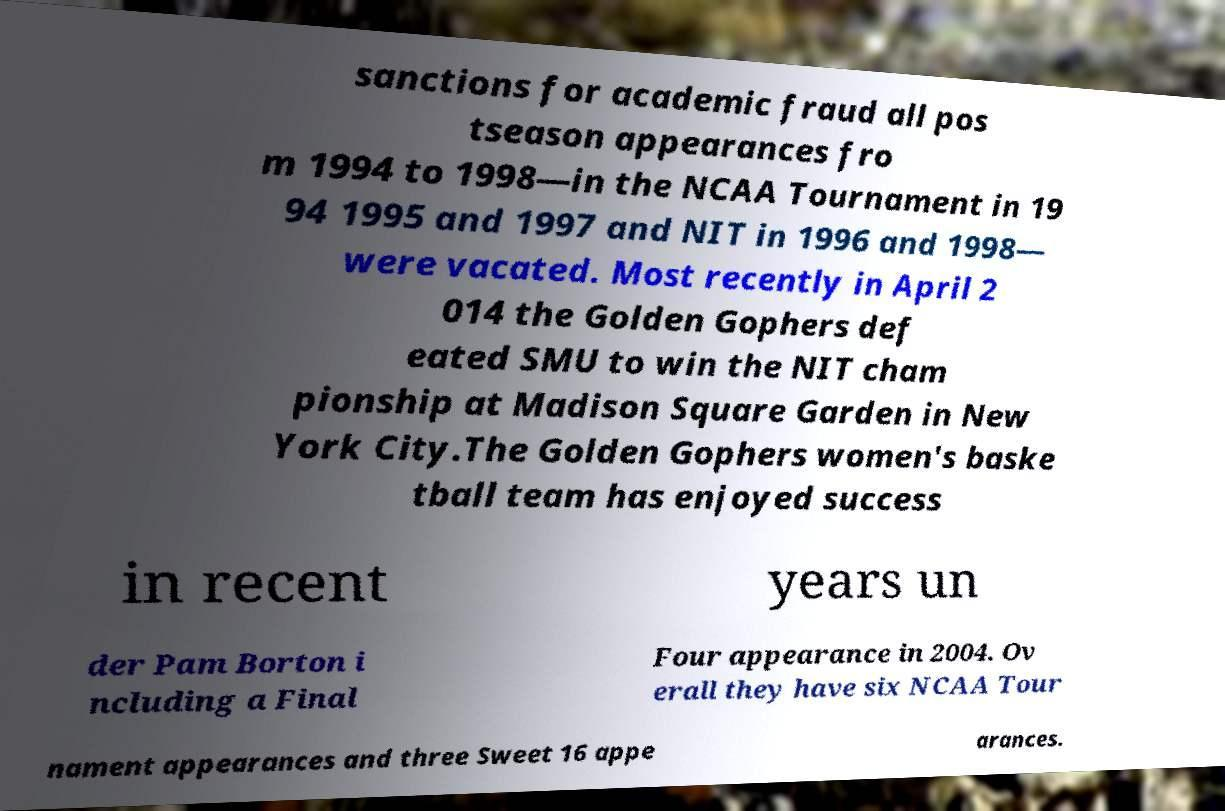There's text embedded in this image that I need extracted. Can you transcribe it verbatim? sanctions for academic fraud all pos tseason appearances fro m 1994 to 1998—in the NCAA Tournament in 19 94 1995 and 1997 and NIT in 1996 and 1998— were vacated. Most recently in April 2 014 the Golden Gophers def eated SMU to win the NIT cham pionship at Madison Square Garden in New York City.The Golden Gophers women's baske tball team has enjoyed success in recent years un der Pam Borton i ncluding a Final Four appearance in 2004. Ov erall they have six NCAA Tour nament appearances and three Sweet 16 appe arances. 